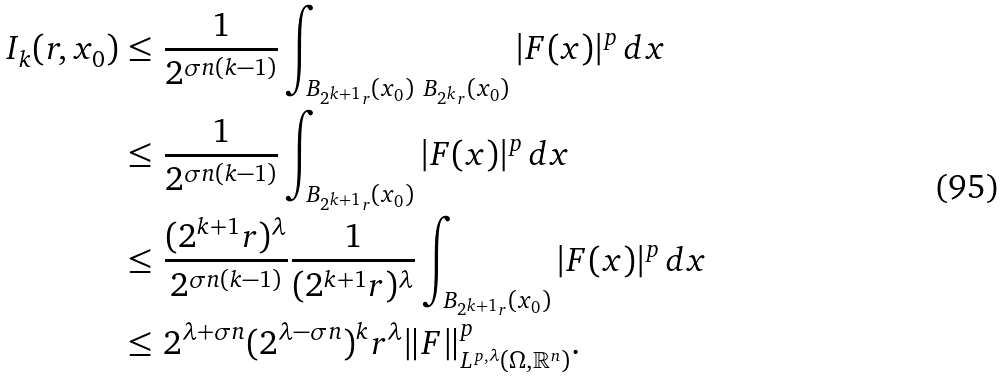Convert formula to latex. <formula><loc_0><loc_0><loc_500><loc_500>I _ { k } ( r , x _ { 0 } ) \leq & \ \frac { 1 } { 2 ^ { \sigma n ( k - 1 ) } } \int _ { B _ { 2 ^ { k + 1 } r } ( x _ { 0 } ) \ B _ { 2 ^ { k } r } ( x _ { 0 } ) } | F ( x ) | ^ { p } \, d x \\ \leq & \ \frac { 1 } { 2 ^ { \sigma n ( k - 1 ) } } \int _ { B _ { 2 ^ { k + 1 } r } ( x _ { 0 } ) } | F ( x ) | ^ { p } \, d x \\ \leq & \ \frac { ( 2 ^ { k + 1 } r ) ^ { \lambda } } { 2 ^ { \sigma n ( k - 1 ) } } \frac { 1 } { ( 2 ^ { k + 1 } r ) ^ { \lambda } } \int _ { B _ { 2 ^ { k + 1 } r } ( x _ { 0 } ) } | F ( x ) | ^ { p } \, d x \\ \leq & \ 2 ^ { \lambda + \sigma n } ( 2 ^ { \lambda - \sigma n } ) ^ { k } r ^ { \lambda } \| F \| _ { L ^ { p , \lambda } ( \Omega , \mathbb { R } ^ { n } ) } ^ { p } .</formula> 